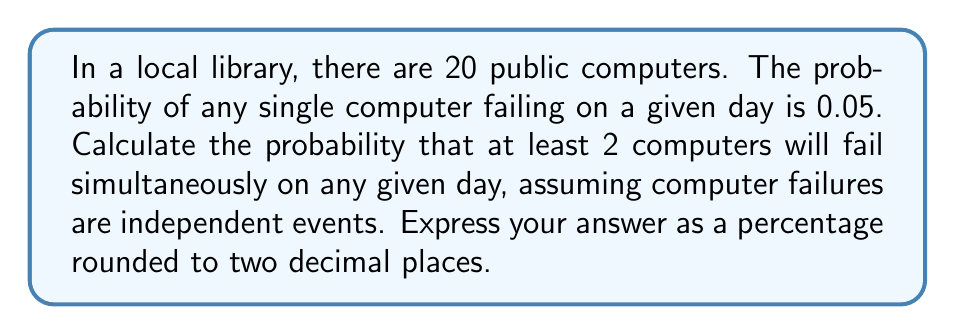Give your solution to this math problem. Let's approach this problem using set theory and probability concepts:

1) First, let's define our sample space and events:
   - Let $S$ be the sample space of all possible outcomes
   - Let $F_i$ be the event that computer $i$ fails, where $i = 1, 2, ..., 20$

2) We're looking for the probability of at least 2 computers failing. It's easier to calculate the complement of this event: the probability of 0 or 1 computer failing.

3) Probability of no computers failing:
   $P(\text{no failures}) = (1 - 0.05)^{20} = 0.95^{20}$

4) Probability of exactly one computer failing:
   $P(\text{one failure}) = \binom{20}{1} \cdot 0.05 \cdot 0.95^{19}$
   
   Here, $\binom{20}{1}$ is the number of ways to choose 1 computer out of 20.

5) Therefore, the probability of 0 or 1 computer failing is:
   $P(0 \text{ or } 1 \text{ failure}) = 0.95^{20} + 20 \cdot 0.05 \cdot 0.95^{19}$

6) The probability of at least 2 computers failing is the complement of this:
   $P(\text{at least 2 failures}) = 1 - P(0 \text{ or } 1 \text{ failure})$
   
   $= 1 - (0.95^{20} + 20 \cdot 0.05 \cdot 0.95^{19})$

7) Calculating this:
   $= 1 - (0.3585 + 0.3774) = 1 - 0.7359 = 0.2641$

8) Converting to a percentage and rounding to two decimal places:
   $0.2641 \cdot 100 \approx 26.41\%$
Answer: 26.41% 